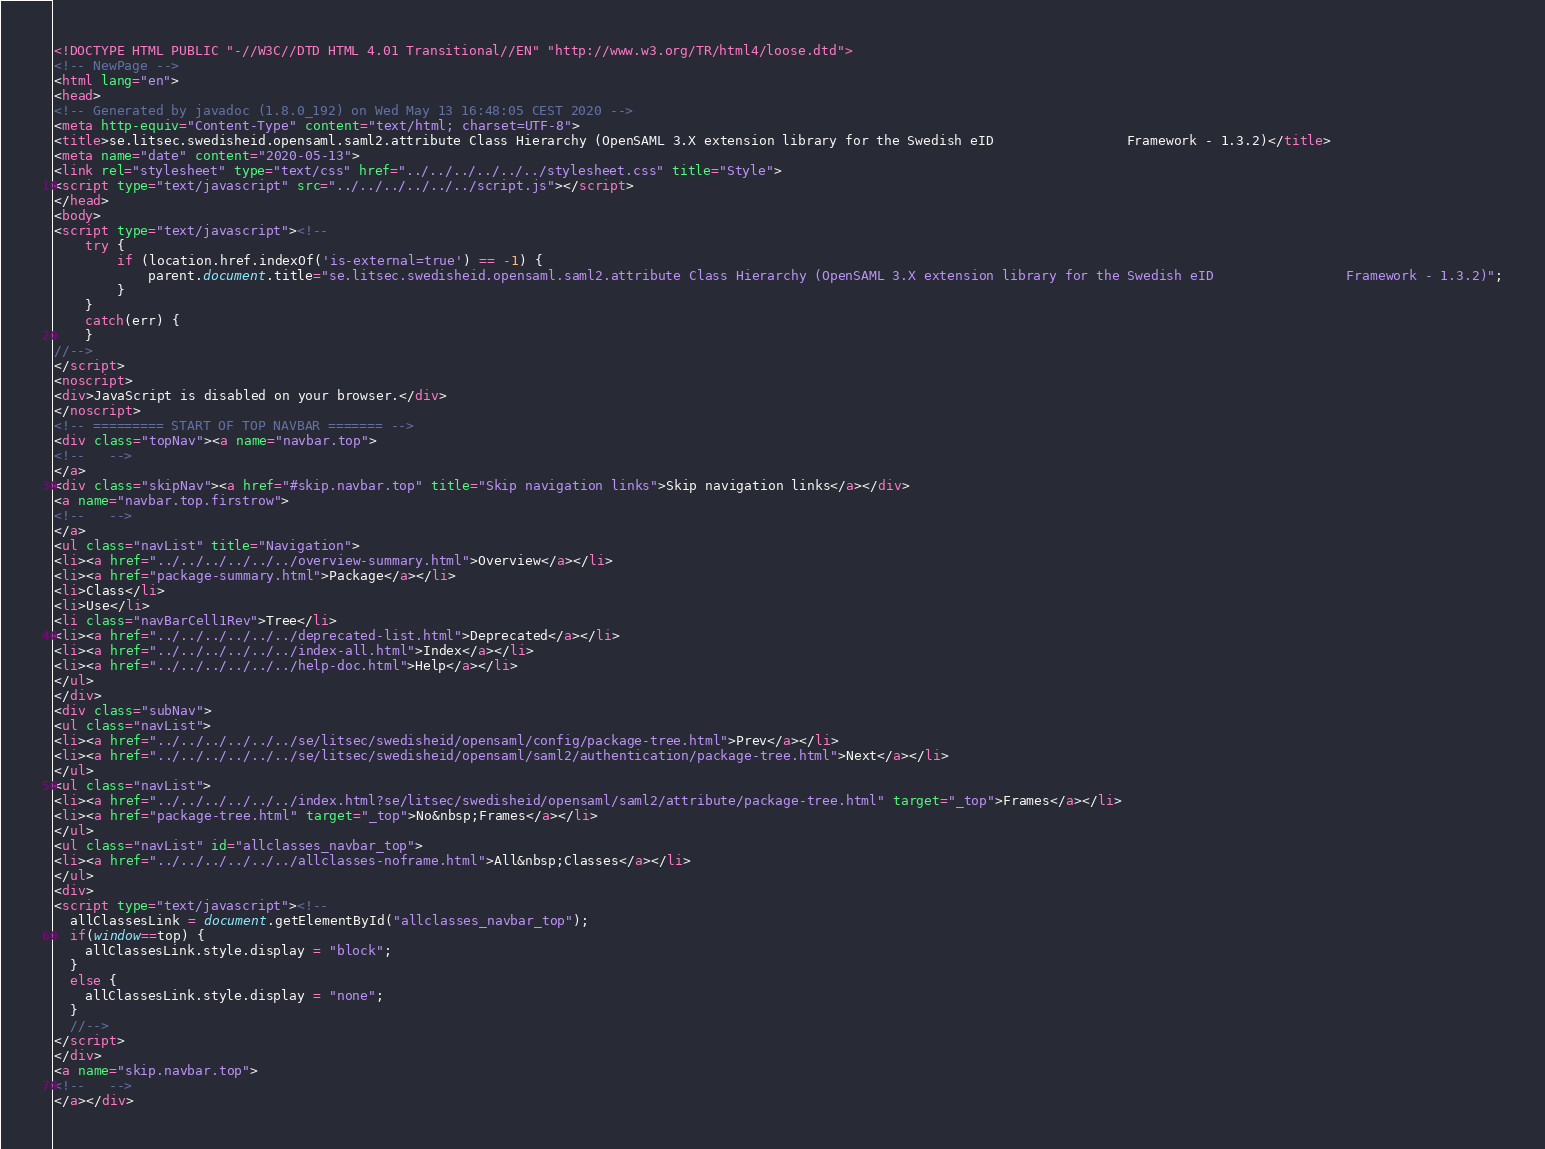<code> <loc_0><loc_0><loc_500><loc_500><_HTML_><!DOCTYPE HTML PUBLIC "-//W3C//DTD HTML 4.01 Transitional//EN" "http://www.w3.org/TR/html4/loose.dtd">
<!-- NewPage -->
<html lang="en">
<head>
<!-- Generated by javadoc (1.8.0_192) on Wed May 13 16:48:05 CEST 2020 -->
<meta http-equiv="Content-Type" content="text/html; charset=UTF-8">
<title>se.litsec.swedisheid.opensaml.saml2.attribute Class Hierarchy (OpenSAML 3.X extension library for the Swedish eID                 Framework - 1.3.2)</title>
<meta name="date" content="2020-05-13">
<link rel="stylesheet" type="text/css" href="../../../../../../stylesheet.css" title="Style">
<script type="text/javascript" src="../../../../../../script.js"></script>
</head>
<body>
<script type="text/javascript"><!--
    try {
        if (location.href.indexOf('is-external=true') == -1) {
            parent.document.title="se.litsec.swedisheid.opensaml.saml2.attribute Class Hierarchy (OpenSAML 3.X extension library for the Swedish eID                 Framework - 1.3.2)";
        }
    }
    catch(err) {
    }
//-->
</script>
<noscript>
<div>JavaScript is disabled on your browser.</div>
</noscript>
<!-- ========= START OF TOP NAVBAR ======= -->
<div class="topNav"><a name="navbar.top">
<!--   -->
</a>
<div class="skipNav"><a href="#skip.navbar.top" title="Skip navigation links">Skip navigation links</a></div>
<a name="navbar.top.firstrow">
<!--   -->
</a>
<ul class="navList" title="Navigation">
<li><a href="../../../../../../overview-summary.html">Overview</a></li>
<li><a href="package-summary.html">Package</a></li>
<li>Class</li>
<li>Use</li>
<li class="navBarCell1Rev">Tree</li>
<li><a href="../../../../../../deprecated-list.html">Deprecated</a></li>
<li><a href="../../../../../../index-all.html">Index</a></li>
<li><a href="../../../../../../help-doc.html">Help</a></li>
</ul>
</div>
<div class="subNav">
<ul class="navList">
<li><a href="../../../../../../se/litsec/swedisheid/opensaml/config/package-tree.html">Prev</a></li>
<li><a href="../../../../../../se/litsec/swedisheid/opensaml/saml2/authentication/package-tree.html">Next</a></li>
</ul>
<ul class="navList">
<li><a href="../../../../../../index.html?se/litsec/swedisheid/opensaml/saml2/attribute/package-tree.html" target="_top">Frames</a></li>
<li><a href="package-tree.html" target="_top">No&nbsp;Frames</a></li>
</ul>
<ul class="navList" id="allclasses_navbar_top">
<li><a href="../../../../../../allclasses-noframe.html">All&nbsp;Classes</a></li>
</ul>
<div>
<script type="text/javascript"><!--
  allClassesLink = document.getElementById("allclasses_navbar_top");
  if(window==top) {
    allClassesLink.style.display = "block";
  }
  else {
    allClassesLink.style.display = "none";
  }
  //-->
</script>
</div>
<a name="skip.navbar.top">
<!--   -->
</a></div></code> 